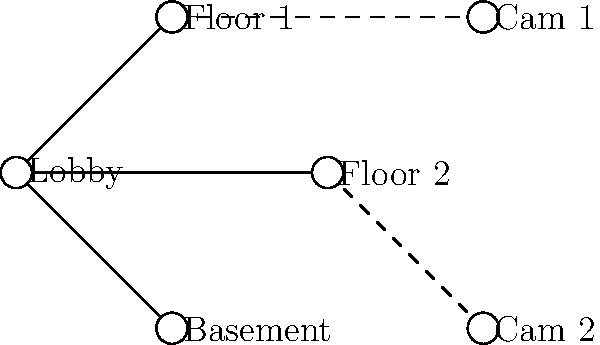Based on the network topology diagram for building security, which area appears to be the most vulnerable due to lack of camera coverage? To determine the most vulnerable area due to lack of camera coverage, let's analyze the diagram step-by-step:

1. Identify the main areas:
   - Lobby (central node)
   - Floor 1
   - Floor 2
   - Basement

2. Locate the security cameras:
   - Cam 1 is connected to Floor 1
   - Cam 2 is connected to Floor 2

3. Assess camera coverage:
   - The Lobby is indirectly covered by both cameras, as it's connected to Floor 1 and Floor 2
   - Floor 1 is directly covered by Cam 1
   - Floor 2 is directly covered by Cam 2
   - The Basement has no direct or indirect camera connection

4. Evaluate vulnerability:
   - The Basement is the only area without any camera coverage, making it the most vulnerable area in terms of surveillance

Therefore, based on the network topology diagram, the Basement appears to be the most vulnerable area due to the lack of camera coverage.
Answer: Basement 